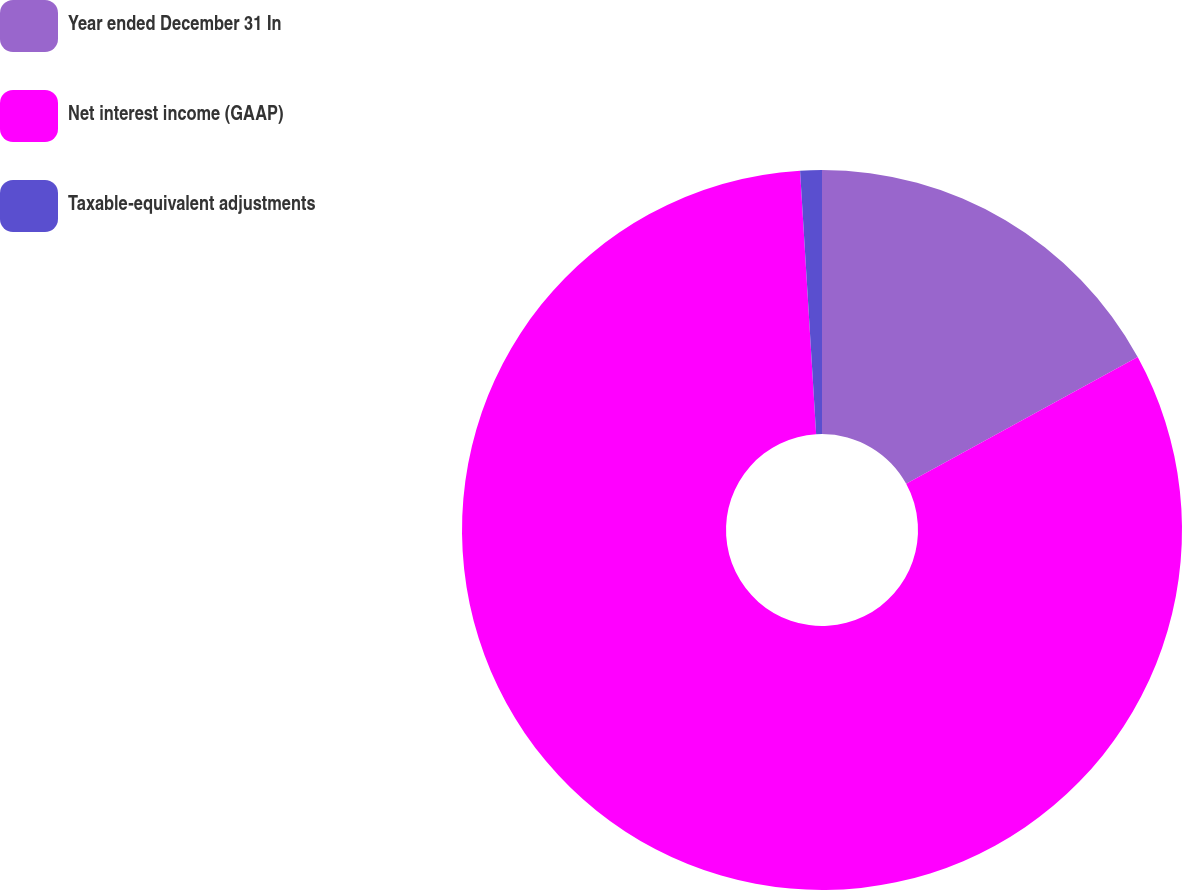Convert chart to OTSL. <chart><loc_0><loc_0><loc_500><loc_500><pie_chart><fcel>Year ended December 31 In<fcel>Net interest income (GAAP)<fcel>Taxable-equivalent adjustments<nl><fcel>17.02%<fcel>82.01%<fcel>0.97%<nl></chart> 